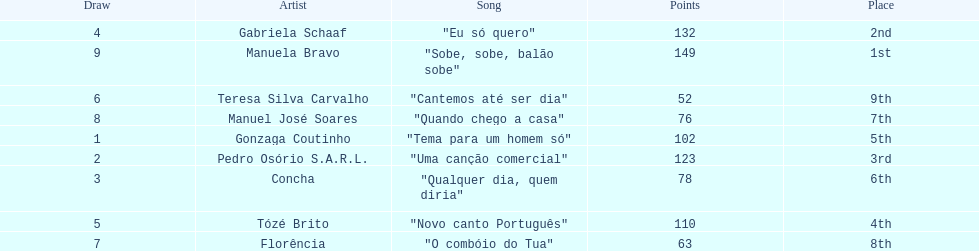Which artist came in last place? Teresa Silva Carvalho. 